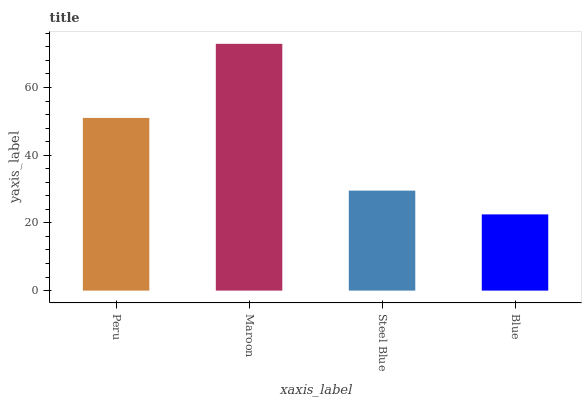Is Blue the minimum?
Answer yes or no. Yes. Is Maroon the maximum?
Answer yes or no. Yes. Is Steel Blue the minimum?
Answer yes or no. No. Is Steel Blue the maximum?
Answer yes or no. No. Is Maroon greater than Steel Blue?
Answer yes or no. Yes. Is Steel Blue less than Maroon?
Answer yes or no. Yes. Is Steel Blue greater than Maroon?
Answer yes or no. No. Is Maroon less than Steel Blue?
Answer yes or no. No. Is Peru the high median?
Answer yes or no. Yes. Is Steel Blue the low median?
Answer yes or no. Yes. Is Blue the high median?
Answer yes or no. No. Is Maroon the low median?
Answer yes or no. No. 